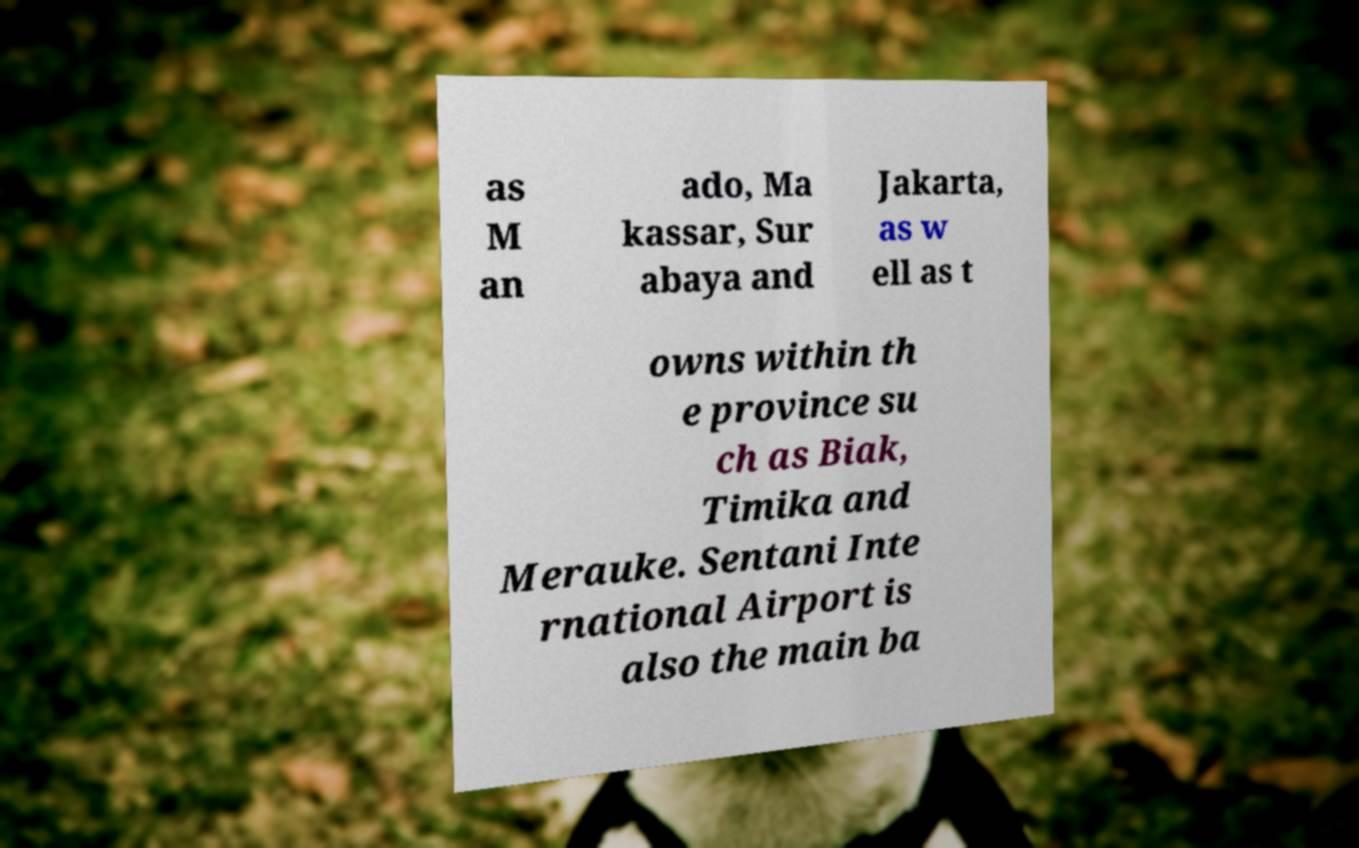I need the written content from this picture converted into text. Can you do that? as M an ado, Ma kassar, Sur abaya and Jakarta, as w ell as t owns within th e province su ch as Biak, Timika and Merauke. Sentani Inte rnational Airport is also the main ba 